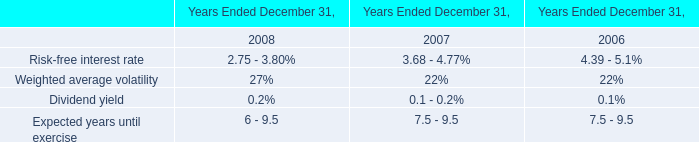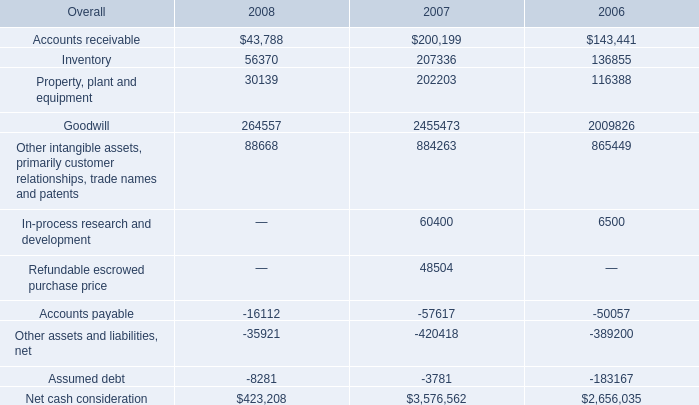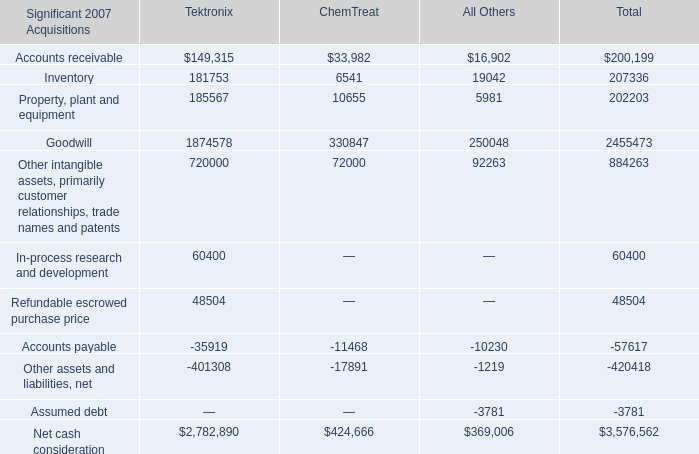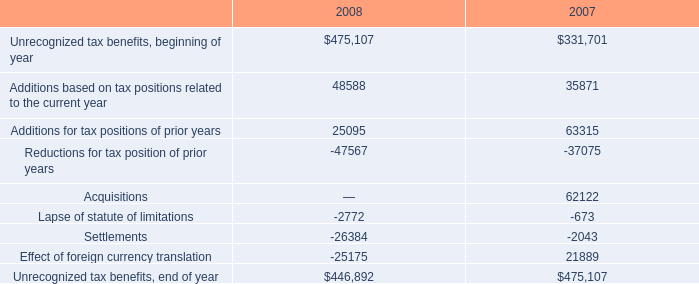How many elements show negative value in 2007 for Tektronix? 
Answer: 2. 